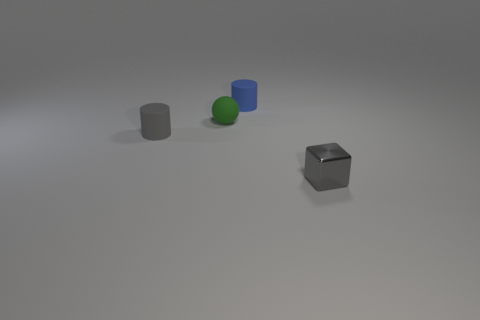Are there any other things that have the same material as the small blue cylinder?
Your answer should be compact. Yes. The other small cylinder that is the same material as the blue cylinder is what color?
Provide a short and direct response. Gray. What number of cylinders have the same color as the metal object?
Your answer should be compact. 1. What is the color of the other small object that is the same shape as the gray rubber thing?
Make the answer very short. Blue. There is a gray object that is the same shape as the tiny blue thing; what is its size?
Make the answer very short. Small. There is a cylinder that is behind the tiny gray matte object; what is its size?
Make the answer very short. Small. Is the number of tiny spheres on the right side of the blue cylinder greater than the number of big red matte blocks?
Provide a short and direct response. No. What is the shape of the green object?
Ensure brevity in your answer.  Sphere. Does the small rubber thing that is on the right side of the tiny green object have the same color as the rubber cylinder that is to the left of the tiny blue object?
Keep it short and to the point. No. Does the gray matte object have the same shape as the tiny blue thing?
Your answer should be very brief. Yes. 